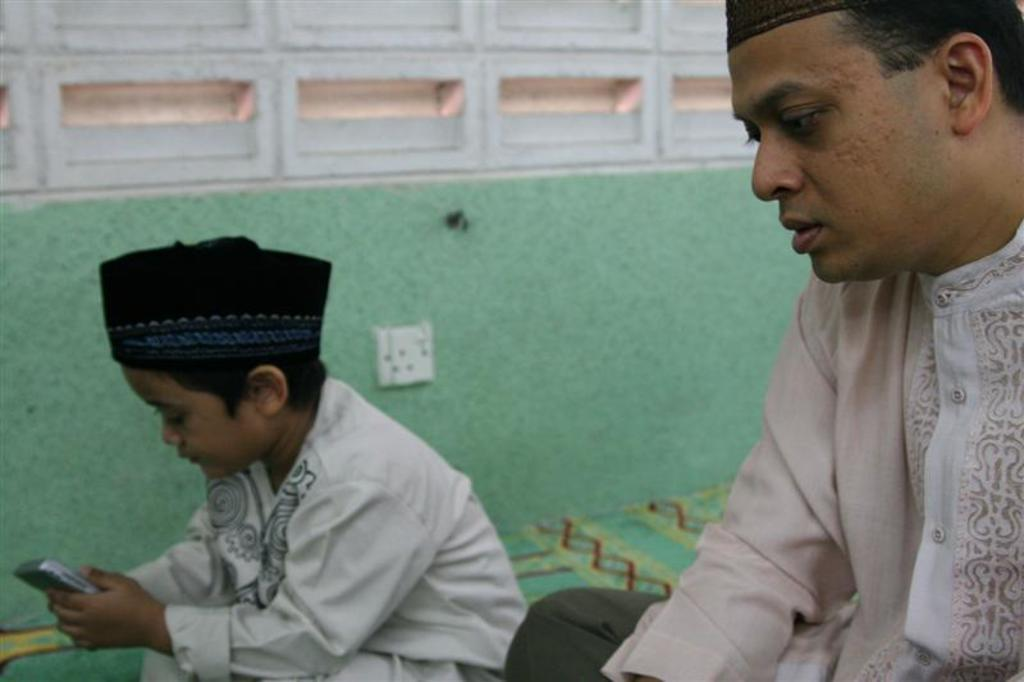How many people are in the image? There are two people in the image. Can you describe one of the people? One of the people is a boy. What is the boy holding in his hands? The boy is holding a mobile in his hands. What can be seen on the wall in the background of the image? There is a switch board on the wall in the background of the image. How many ducks are visible in the image? There are no ducks present in the image. Can you describe the boy's body in the image? The provided facts do not mention any details about the boy's body, so we cannot describe it. 